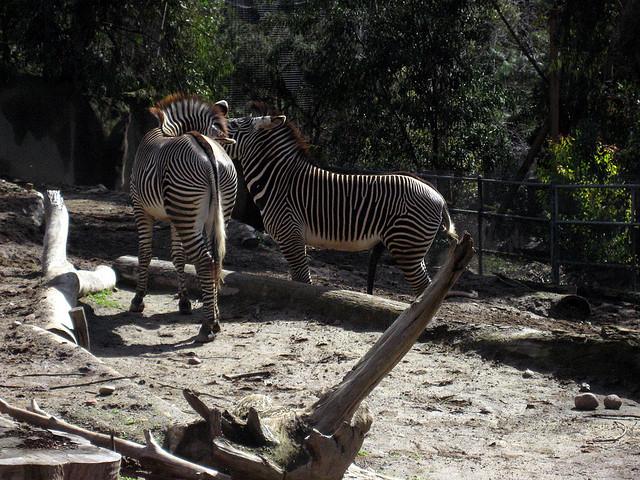Are the zebras near each other?
Be succinct. Yes. Who took this picture?
Keep it brief. Tourist. Where is a log?
Quick response, please. On ground. What colors are the zebras?
Be succinct. Black and white. 